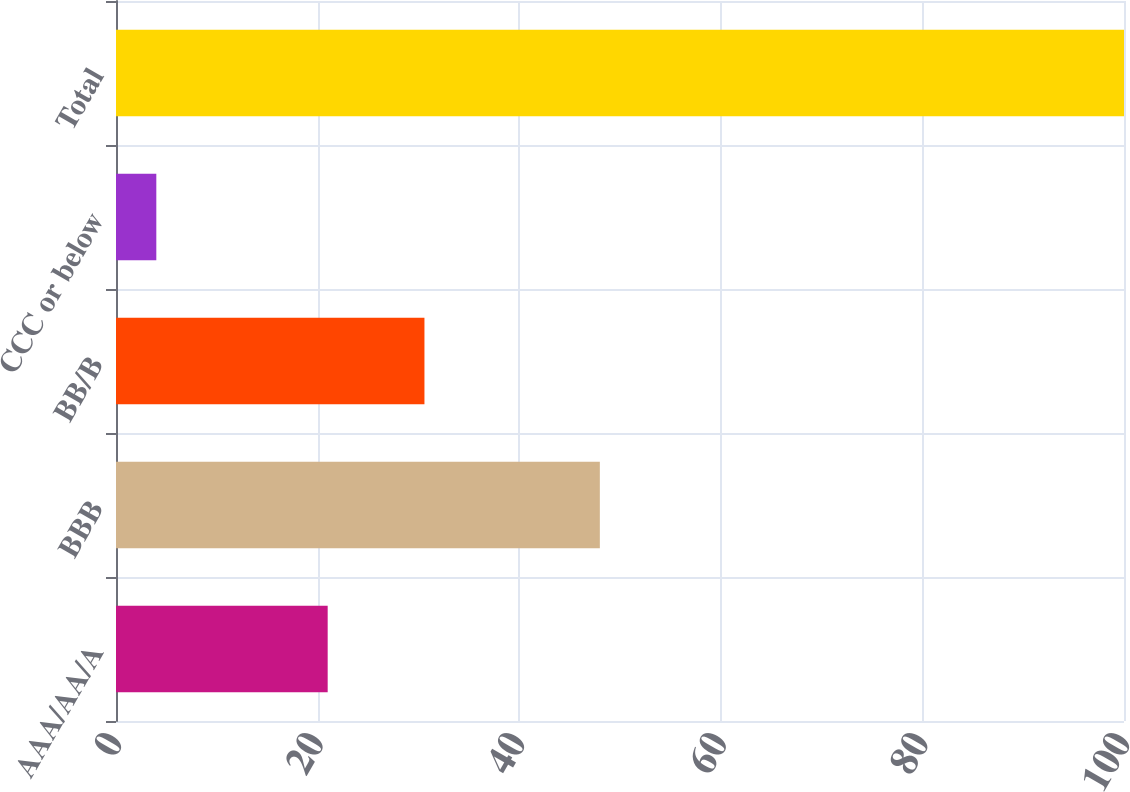<chart> <loc_0><loc_0><loc_500><loc_500><bar_chart><fcel>AAA/AA/A<fcel>BBB<fcel>BB/B<fcel>CCC or below<fcel>Total<nl><fcel>21<fcel>48<fcel>30.6<fcel>4<fcel>100<nl></chart> 